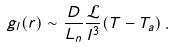<formula> <loc_0><loc_0><loc_500><loc_500>g _ { l } ( r ) \sim \frac { D } { L _ { n } } \frac { \mathcal { L } } { l ^ { 3 } } ( T - T _ { a } ) \, .</formula> 